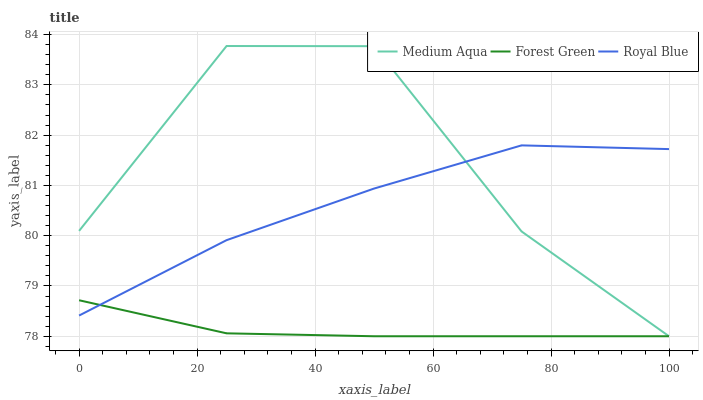Does Forest Green have the minimum area under the curve?
Answer yes or no. Yes. Does Medium Aqua have the maximum area under the curve?
Answer yes or no. Yes. Does Medium Aqua have the minimum area under the curve?
Answer yes or no. No. Does Forest Green have the maximum area under the curve?
Answer yes or no. No. Is Forest Green the smoothest?
Answer yes or no. Yes. Is Medium Aqua the roughest?
Answer yes or no. Yes. Is Medium Aqua the smoothest?
Answer yes or no. No. Is Forest Green the roughest?
Answer yes or no. No. Does Forest Green have the lowest value?
Answer yes or no. Yes. Does Medium Aqua have the highest value?
Answer yes or no. Yes. Does Forest Green have the highest value?
Answer yes or no. No. Does Medium Aqua intersect Forest Green?
Answer yes or no. Yes. Is Medium Aqua less than Forest Green?
Answer yes or no. No. Is Medium Aqua greater than Forest Green?
Answer yes or no. No. 